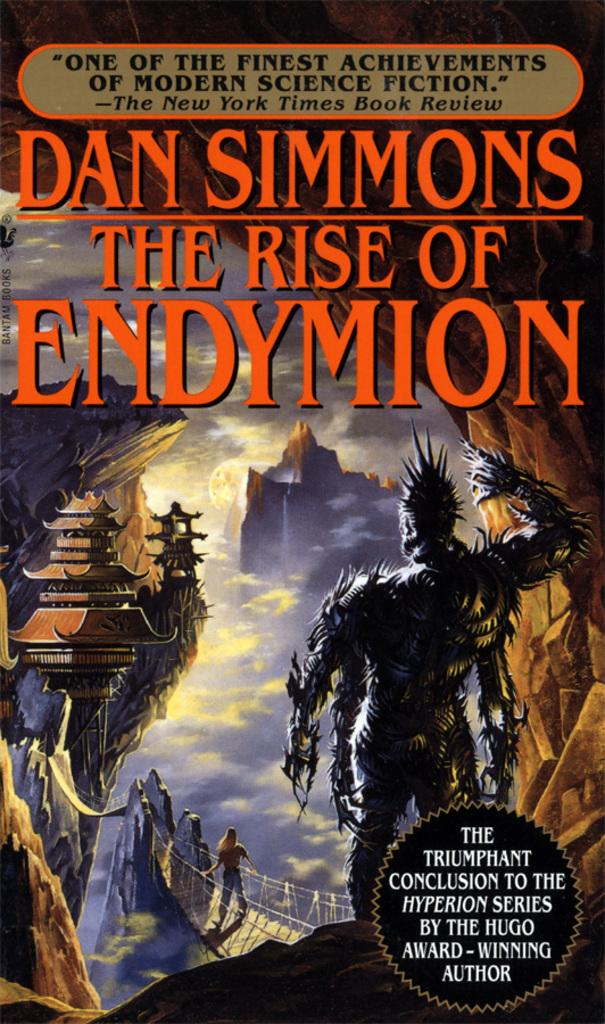What type of image is being described? The image is a cover page of a book. What can be seen on the cover page? There is a person standing on the cover page, and another person standing on a bridge. Is there any text or writing on the cover page? Yes, there is text or writing on the cover page. What is the taste of the bridge in the image? There is no taste associated with the bridge in the image, as it is a physical structure and not a food item. 